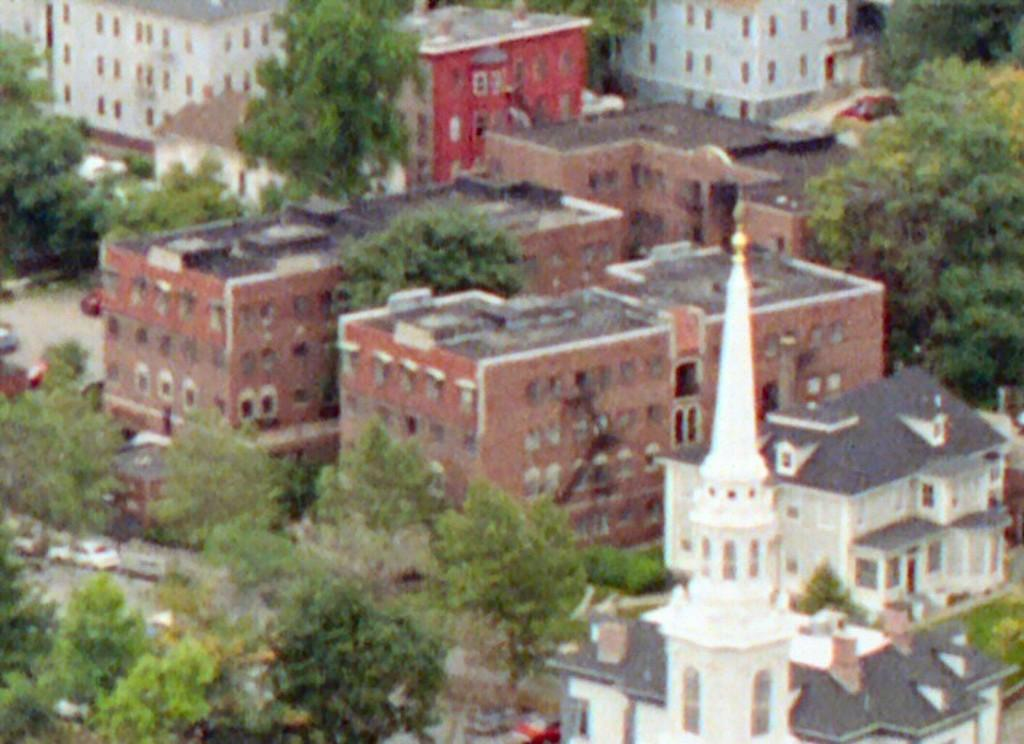What type of structures can be seen in the image? There are buildings in the image. What is the purpose of the road in the image? The road in the image is used for vehicles to travel on. What types of vehicles are visible in the image? There are vehicles in the image. What type of natural elements can be seen in the image? There are trees and plants in the image. Can you tell me how many people are swimming in the image? There is no swimming or people present in the image; it features buildings, a road, vehicles, trees, and plants. What type of street is shown in the image? The image does not show a specific street; it simply features a road with vehicles and buildings. 